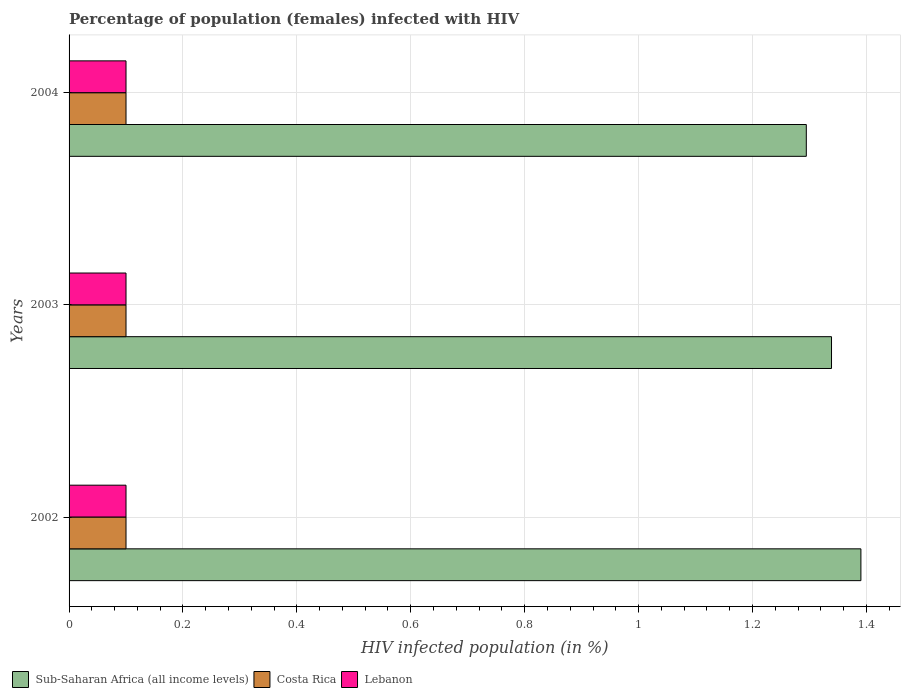How many different coloured bars are there?
Keep it short and to the point. 3. Are the number of bars per tick equal to the number of legend labels?
Provide a short and direct response. Yes. How many bars are there on the 2nd tick from the top?
Offer a terse response. 3. What is the label of the 3rd group of bars from the top?
Provide a succinct answer. 2002. In how many cases, is the number of bars for a given year not equal to the number of legend labels?
Your answer should be compact. 0. What is the percentage of HIV infected female population in Sub-Saharan Africa (all income levels) in 2004?
Your response must be concise. 1.29. Across all years, what is the minimum percentage of HIV infected female population in Lebanon?
Provide a succinct answer. 0.1. In which year was the percentage of HIV infected female population in Sub-Saharan Africa (all income levels) maximum?
Ensure brevity in your answer.  2002. In which year was the percentage of HIV infected female population in Lebanon minimum?
Make the answer very short. 2002. What is the total percentage of HIV infected female population in Lebanon in the graph?
Your answer should be compact. 0.3. What is the difference between the percentage of HIV infected female population in Sub-Saharan Africa (all income levels) in 2002 and that in 2004?
Make the answer very short. 0.1. What is the difference between the percentage of HIV infected female population in Sub-Saharan Africa (all income levels) in 2004 and the percentage of HIV infected female population in Costa Rica in 2002?
Your answer should be very brief. 1.19. What is the average percentage of HIV infected female population in Sub-Saharan Africa (all income levels) per year?
Your answer should be compact. 1.34. In the year 2004, what is the difference between the percentage of HIV infected female population in Lebanon and percentage of HIV infected female population in Sub-Saharan Africa (all income levels)?
Ensure brevity in your answer.  -1.19. What is the ratio of the percentage of HIV infected female population in Sub-Saharan Africa (all income levels) in 2002 to that in 2004?
Offer a terse response. 1.07. What is the difference between the highest and the second highest percentage of HIV infected female population in Sub-Saharan Africa (all income levels)?
Offer a terse response. 0.05. What is the difference between the highest and the lowest percentage of HIV infected female population in Costa Rica?
Provide a short and direct response. 0. In how many years, is the percentage of HIV infected female population in Costa Rica greater than the average percentage of HIV infected female population in Costa Rica taken over all years?
Make the answer very short. 0. Is the sum of the percentage of HIV infected female population in Lebanon in 2002 and 2003 greater than the maximum percentage of HIV infected female population in Costa Rica across all years?
Give a very brief answer. Yes. What does the 2nd bar from the top in 2003 represents?
Keep it short and to the point. Costa Rica. What does the 3rd bar from the bottom in 2004 represents?
Keep it short and to the point. Lebanon. How many years are there in the graph?
Keep it short and to the point. 3. What is the difference between two consecutive major ticks on the X-axis?
Keep it short and to the point. 0.2. Does the graph contain any zero values?
Provide a succinct answer. No. Does the graph contain grids?
Offer a very short reply. Yes. Where does the legend appear in the graph?
Make the answer very short. Bottom left. What is the title of the graph?
Offer a terse response. Percentage of population (females) infected with HIV. Does "Eritrea" appear as one of the legend labels in the graph?
Offer a very short reply. No. What is the label or title of the X-axis?
Provide a short and direct response. HIV infected population (in %). What is the HIV infected population (in %) in Sub-Saharan Africa (all income levels) in 2002?
Your response must be concise. 1.39. What is the HIV infected population (in %) in Costa Rica in 2002?
Make the answer very short. 0.1. What is the HIV infected population (in %) in Lebanon in 2002?
Give a very brief answer. 0.1. What is the HIV infected population (in %) of Sub-Saharan Africa (all income levels) in 2003?
Your answer should be very brief. 1.34. What is the HIV infected population (in %) of Costa Rica in 2003?
Give a very brief answer. 0.1. What is the HIV infected population (in %) of Lebanon in 2003?
Give a very brief answer. 0.1. What is the HIV infected population (in %) in Sub-Saharan Africa (all income levels) in 2004?
Make the answer very short. 1.29. What is the HIV infected population (in %) of Lebanon in 2004?
Offer a very short reply. 0.1. Across all years, what is the maximum HIV infected population (in %) of Sub-Saharan Africa (all income levels)?
Keep it short and to the point. 1.39. Across all years, what is the maximum HIV infected population (in %) of Costa Rica?
Your response must be concise. 0.1. Across all years, what is the maximum HIV infected population (in %) in Lebanon?
Offer a very short reply. 0.1. Across all years, what is the minimum HIV infected population (in %) of Sub-Saharan Africa (all income levels)?
Ensure brevity in your answer.  1.29. Across all years, what is the minimum HIV infected population (in %) of Lebanon?
Give a very brief answer. 0.1. What is the total HIV infected population (in %) of Sub-Saharan Africa (all income levels) in the graph?
Make the answer very short. 4.02. What is the total HIV infected population (in %) in Lebanon in the graph?
Ensure brevity in your answer.  0.3. What is the difference between the HIV infected population (in %) in Sub-Saharan Africa (all income levels) in 2002 and that in 2003?
Give a very brief answer. 0.05. What is the difference between the HIV infected population (in %) in Sub-Saharan Africa (all income levels) in 2002 and that in 2004?
Provide a succinct answer. 0.1. What is the difference between the HIV infected population (in %) in Costa Rica in 2002 and that in 2004?
Your answer should be very brief. 0. What is the difference between the HIV infected population (in %) of Sub-Saharan Africa (all income levels) in 2003 and that in 2004?
Provide a short and direct response. 0.04. What is the difference between the HIV infected population (in %) in Lebanon in 2003 and that in 2004?
Give a very brief answer. 0. What is the difference between the HIV infected population (in %) of Sub-Saharan Africa (all income levels) in 2002 and the HIV infected population (in %) of Costa Rica in 2003?
Your answer should be very brief. 1.29. What is the difference between the HIV infected population (in %) of Sub-Saharan Africa (all income levels) in 2002 and the HIV infected population (in %) of Lebanon in 2003?
Keep it short and to the point. 1.29. What is the difference between the HIV infected population (in %) in Costa Rica in 2002 and the HIV infected population (in %) in Lebanon in 2003?
Provide a succinct answer. 0. What is the difference between the HIV infected population (in %) of Sub-Saharan Africa (all income levels) in 2002 and the HIV infected population (in %) of Costa Rica in 2004?
Keep it short and to the point. 1.29. What is the difference between the HIV infected population (in %) in Sub-Saharan Africa (all income levels) in 2002 and the HIV infected population (in %) in Lebanon in 2004?
Your response must be concise. 1.29. What is the difference between the HIV infected population (in %) in Costa Rica in 2002 and the HIV infected population (in %) in Lebanon in 2004?
Offer a very short reply. 0. What is the difference between the HIV infected population (in %) of Sub-Saharan Africa (all income levels) in 2003 and the HIV infected population (in %) of Costa Rica in 2004?
Offer a terse response. 1.24. What is the difference between the HIV infected population (in %) in Sub-Saharan Africa (all income levels) in 2003 and the HIV infected population (in %) in Lebanon in 2004?
Keep it short and to the point. 1.24. What is the difference between the HIV infected population (in %) in Costa Rica in 2003 and the HIV infected population (in %) in Lebanon in 2004?
Provide a short and direct response. 0. What is the average HIV infected population (in %) in Sub-Saharan Africa (all income levels) per year?
Provide a short and direct response. 1.34. What is the average HIV infected population (in %) in Lebanon per year?
Provide a succinct answer. 0.1. In the year 2002, what is the difference between the HIV infected population (in %) of Sub-Saharan Africa (all income levels) and HIV infected population (in %) of Costa Rica?
Ensure brevity in your answer.  1.29. In the year 2002, what is the difference between the HIV infected population (in %) in Sub-Saharan Africa (all income levels) and HIV infected population (in %) in Lebanon?
Provide a succinct answer. 1.29. In the year 2003, what is the difference between the HIV infected population (in %) in Sub-Saharan Africa (all income levels) and HIV infected population (in %) in Costa Rica?
Your response must be concise. 1.24. In the year 2003, what is the difference between the HIV infected population (in %) of Sub-Saharan Africa (all income levels) and HIV infected population (in %) of Lebanon?
Give a very brief answer. 1.24. In the year 2004, what is the difference between the HIV infected population (in %) in Sub-Saharan Africa (all income levels) and HIV infected population (in %) in Costa Rica?
Your answer should be compact. 1.19. In the year 2004, what is the difference between the HIV infected population (in %) of Sub-Saharan Africa (all income levels) and HIV infected population (in %) of Lebanon?
Provide a short and direct response. 1.19. What is the ratio of the HIV infected population (in %) in Costa Rica in 2002 to that in 2003?
Make the answer very short. 1. What is the ratio of the HIV infected population (in %) in Lebanon in 2002 to that in 2003?
Your answer should be compact. 1. What is the ratio of the HIV infected population (in %) of Sub-Saharan Africa (all income levels) in 2002 to that in 2004?
Provide a short and direct response. 1.07. What is the ratio of the HIV infected population (in %) in Sub-Saharan Africa (all income levels) in 2003 to that in 2004?
Give a very brief answer. 1.03. What is the ratio of the HIV infected population (in %) of Costa Rica in 2003 to that in 2004?
Keep it short and to the point. 1. What is the ratio of the HIV infected population (in %) of Lebanon in 2003 to that in 2004?
Your response must be concise. 1. What is the difference between the highest and the second highest HIV infected population (in %) in Sub-Saharan Africa (all income levels)?
Give a very brief answer. 0.05. What is the difference between the highest and the second highest HIV infected population (in %) of Lebanon?
Offer a very short reply. 0. What is the difference between the highest and the lowest HIV infected population (in %) in Sub-Saharan Africa (all income levels)?
Make the answer very short. 0.1. What is the difference between the highest and the lowest HIV infected population (in %) of Lebanon?
Make the answer very short. 0. 